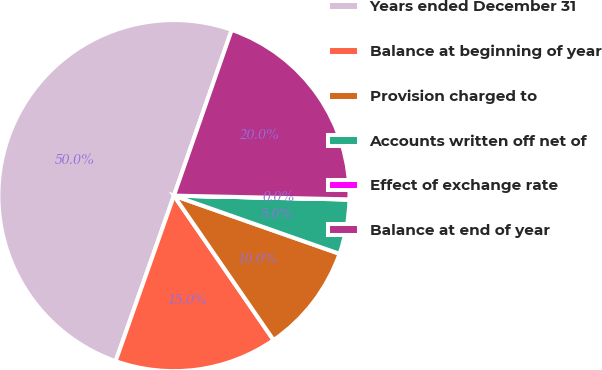Convert chart to OTSL. <chart><loc_0><loc_0><loc_500><loc_500><pie_chart><fcel>Years ended December 31<fcel>Balance at beginning of year<fcel>Provision charged to<fcel>Accounts written off net of<fcel>Effect of exchange rate<fcel>Balance at end of year<nl><fcel>49.95%<fcel>15.0%<fcel>10.01%<fcel>5.02%<fcel>0.02%<fcel>20.0%<nl></chart> 